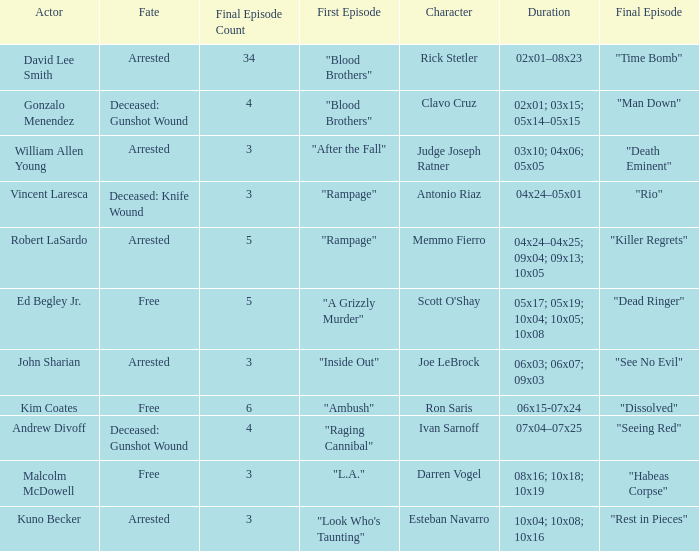Could you parse the entire table? {'header': ['Actor', 'Fate', 'Final Episode Count', 'First Episode', 'Character', 'Duration', 'Final Episode'], 'rows': [['David Lee Smith', 'Arrested', '34', '"Blood Brothers"', 'Rick Stetler', '02x01–08x23', '"Time Bomb"'], ['Gonzalo Menendez', 'Deceased: Gunshot Wound', '4', '"Blood Brothers"', 'Clavo Cruz', '02x01; 03x15; 05x14–05x15', '"Man Down"'], ['William Allen Young', 'Arrested', '3', '"After the Fall"', 'Judge Joseph Ratner', '03x10; 04x06; 05x05', '"Death Eminent"'], ['Vincent Laresca', 'Deceased: Knife Wound', '3', '"Rampage"', 'Antonio Riaz', '04x24–05x01', '"Rio"'], ['Robert LaSardo', 'Arrested', '5', '"Rampage"', 'Memmo Fierro', '04x24–04x25; 09x04; 09x13; 10x05', '"Killer Regrets"'], ['Ed Begley Jr.', 'Free', '5', '"A Grizzly Murder"', "Scott O'Shay", '05x17; 05x19; 10x04; 10x05; 10x08', '"Dead Ringer"'], ['John Sharian', 'Arrested', '3', '"Inside Out"', 'Joe LeBrock', '06x03; 06x07; 09x03', '"See No Evil"'], ['Kim Coates', 'Free', '6', '"Ambush"', 'Ron Saris', '06x15-07x24', '"Dissolved"'], ['Andrew Divoff', 'Deceased: Gunshot Wound', '4', '"Raging Cannibal"', 'Ivan Sarnoff', '07x04–07x25', '"Seeing Red"'], ['Malcolm McDowell', 'Free', '3', '"L.A."', 'Darren Vogel', '08x16; 10x18; 10x19', '"Habeas Corpse"'], ['Kuno Becker', 'Arrested', '3', '"Look Who\'s Taunting"', 'Esteban Navarro', '10x04; 10x08; 10x16', '"Rest in Pieces"']]} What's the persona with fate being expired: knife cut? Antonio Riaz. 